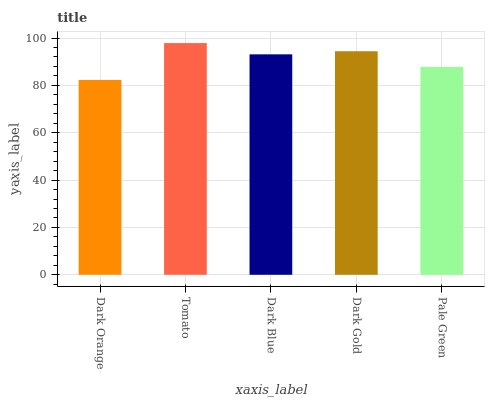Is Dark Orange the minimum?
Answer yes or no. Yes. Is Tomato the maximum?
Answer yes or no. Yes. Is Dark Blue the minimum?
Answer yes or no. No. Is Dark Blue the maximum?
Answer yes or no. No. Is Tomato greater than Dark Blue?
Answer yes or no. Yes. Is Dark Blue less than Tomato?
Answer yes or no. Yes. Is Dark Blue greater than Tomato?
Answer yes or no. No. Is Tomato less than Dark Blue?
Answer yes or no. No. Is Dark Blue the high median?
Answer yes or no. Yes. Is Dark Blue the low median?
Answer yes or no. Yes. Is Pale Green the high median?
Answer yes or no. No. Is Pale Green the low median?
Answer yes or no. No. 